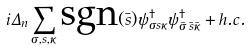<formula> <loc_0><loc_0><loc_500><loc_500>i \Delta _ { n } \sum _ { \sigma , s , \kappa } \text {sgn} ( \bar { s } ) \psi _ { \sigma s \kappa } ^ { \dagger } \psi _ { \bar { \sigma } \, \bar { s } \bar { \kappa } } ^ { \dagger } + h . c .</formula> 